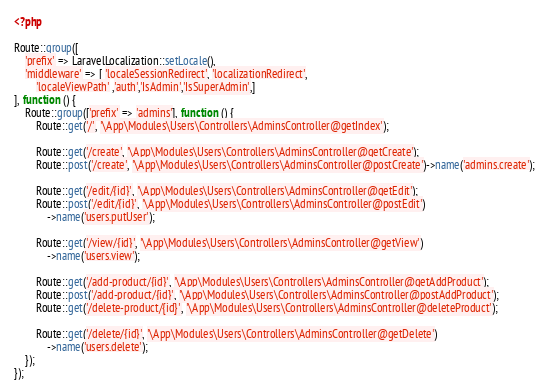Convert code to text. <code><loc_0><loc_0><loc_500><loc_500><_PHP_><?php

Route::group([
    'prefix' => LaravelLocalization::setLocale(),
    'middleware' => [ 'localeSessionRedirect', 'localizationRedirect',
        'localeViewPath' ,'auth','IsAdmin','IsSuperAdmin',]
], function () {
    Route::group(['prefix' => 'admins'], function () {
        Route::get('/', '\App\Modules\Users\Controllers\AdminsController@getIndex');

        Route::get('/create', '\App\Modules\Users\Controllers\AdminsController@getCreate');
        Route::post('/create', '\App\Modules\Users\Controllers\AdminsController@postCreate')->name('admins.create');

        Route::get('/edit/{id}', '\App\Modules\Users\Controllers\AdminsController@getEdit');
        Route::post('/edit/{id}', '\App\Modules\Users\Controllers\AdminsController@postEdit')
            ->name('users.putUser');

        Route::get('/view/{id}', '\App\Modules\Users\Controllers\AdminsController@getView')
            ->name('users.view');

        Route::get('/add-product/{id}', '\App\Modules\Users\Controllers\AdminsController@getAddProduct');
        Route::post('/add-product/{id}', '\App\Modules\Users\Controllers\AdminsController@postAddProduct');
        Route::get('/delete-product/{id}', '\App\Modules\Users\Controllers\AdminsController@deleteProduct');

        Route::get('/delete/{id}', '\App\Modules\Users\Controllers\AdminsController@getDelete')
            ->name('users.delete');
    });
});
</code> 